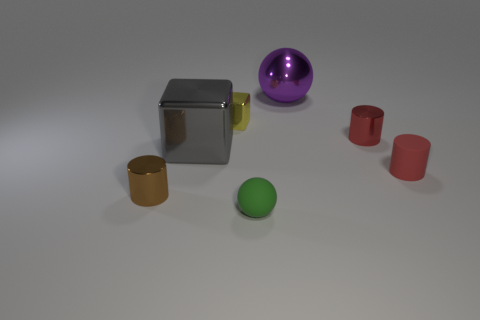How would the scene be different if the purple object were in the place of the green object? If the purple sphere were to be placed where the green one currently is, it would likely command more attention due to its larger size and more reflective surface, creating a visually dominant feature within the composition. Furthermore, the balance of colors would shift, potentially making the scene feel less evenly distributed. 